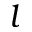<formula> <loc_0><loc_0><loc_500><loc_500>l</formula> 